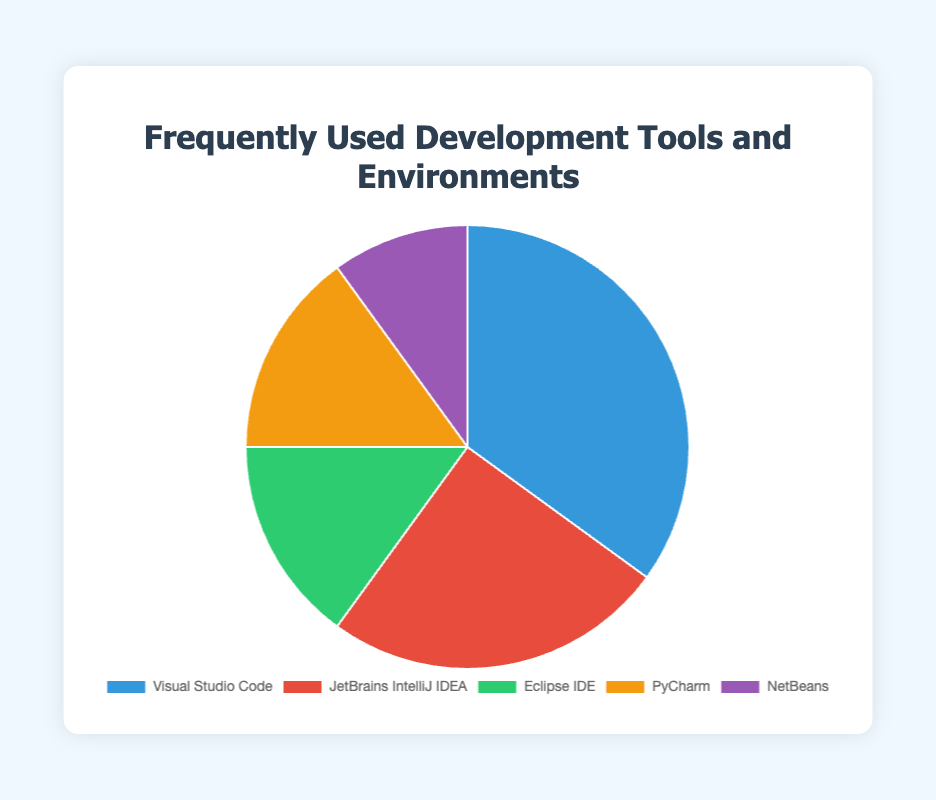Which development tool has the highest usage percentage? The highest usage percentage is determined by identifying the largest value in the chart. Visual Studio Code has the highest usage percentage at 35%.
Answer: Visual Studio Code What is the combined usage percentage of Eclipse IDE and NetBeans? Sum the usage percentages of Eclipse IDE (15%) and NetBeans (10%). 15% + 10% = 25%
Answer: 25% Which tool has an equal usage percentage to PyCharm? Both PyCharm and Eclipse IDE have the same usage percentage of 15%.
Answer: Eclipse IDE How much more popular is Visual Studio Code compared to JetBrains IntelliJ IDEA? Subtract the usage percentage of JetBrains IntelliJ IDEA (25%) from Visual Studio Code (35%). 35% - 25% = 10%
Answer: 10% Is JetBrains IntelliJ IDEA more popular than PyCharm? Compare the usage percentages of JetBrains IntelliJ IDEA (25%) and PyCharm (15%). 25% is greater than 15%, so JetBrains IntelliJ IDEA is more popular.
Answer: Yes Which tool has the lowest usage percentage, and what is it? Identify the tool with the smallest percentage in the chart. NetBeans has the lowest usage percentage at 10%.
Answer: NetBeans, 10% What is the average usage percentage of all the development tools? Sum all the usage percentages: 35% + 25% + 15% + 15% + 10% = 100%. Divide by the number of tools: 100% / 5 = 20%
Answer: 20% How many tools have a usage percentage greater than or equal to 15%? Count the tools with usage percentages 35%, 25%, 15%, and 15%, which are all greater than or equal to 15%. There are 4 such tools.
Answer: 4 Is there any tool with a usage percentage less than 10%? Review the chart for any usage percentages below 10%. Since the smallest percentage is 10% (NetBeans), no tool has a percentage less than 10%.
Answer: No What is the difference in usage percentage between the most and the least used development tool? Subtract the usage percentage of the least used tool (NetBeans, 10%) from the most used tool (Visual Studio Code, 35%). 35% - 10% = 25%
Answer: 25% 